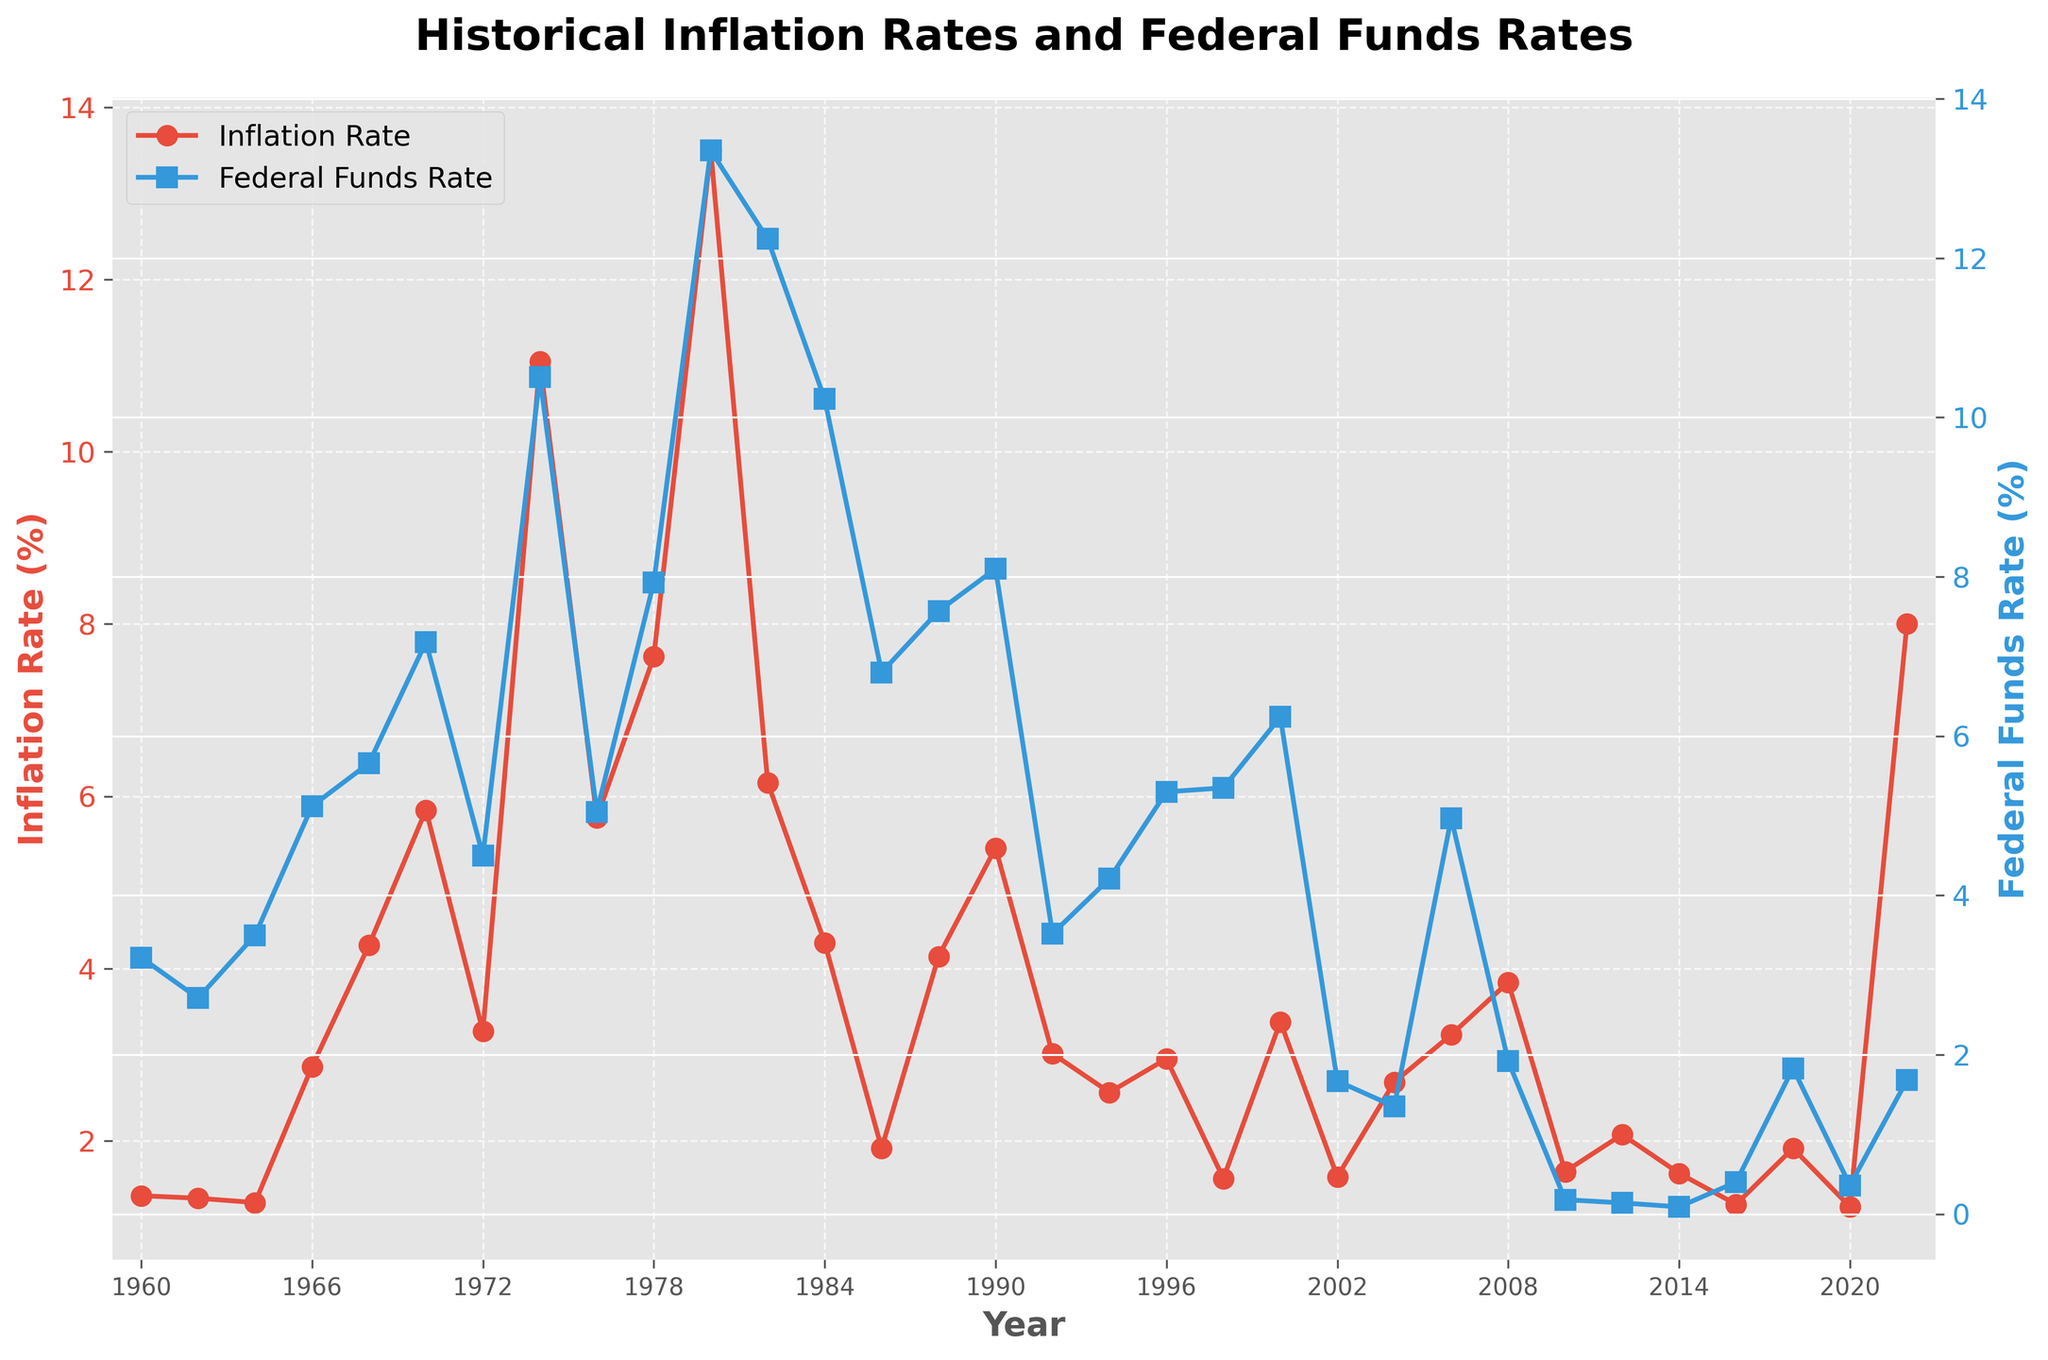Which year had the highest inflation rate? To determine the year with the highest inflation rate, look at the red line representing the inflation rate and find the highest point on this line. The data labels also help identify this year.
Answer: 1980 Which year had the lowest Federal Funds Rate? To determine the year with the lowest Federal Funds Rate, look at the blue line representing the Federal Funds Rate and identify the lowest point on this line. The data labels also assist in this identification.
Answer: 2014 In how many years did the inflation rate exceed 10%? Check the red line graph for years where the inflation rate is above 10%. Count the number of these occurrences.
Answer: 2 What was the inflation rate in 1990 compared to 1986? Look at the red line plot and find the data points for the years 1990 and 1986. Compare the values to determine which is higher or if they are equal.
Answer: 1990 was higher During which period was the gap between the Inflation Rate and Federal Funds Rate the highest? Examine the difference between the red and blue lines over the years. Identify the period where this vertical gap is the largest.
Answer: 1982 By how much did the Federal Funds Rate decrease between 1984 and 1986? Locate the data points for 1984 and 1986 on the blue line plot. Subtract the rate in 1986 from the rate in 1984 to find the difference.
Answer: 3.43% Compare the Inflation Rate in 2022 to the Federal Funds Rate in 2022. Find the rates for the year 2022 for both inflation (red line) and Federal Funds Rate (blue line) and compare which is higher.
Answer: Inflation Rate was higher Which color represents the Federal Funds Rate in the plot? Identify the color of the line that represents the Federal Funds Rate by looking at the blue line in the chart.
Answer: Blue How did the Federal Funds Rate change from 1960 to 1966? Examine the blue line from 1960 to 1966. Identify the Federal Funds Rate in 1960 and 1966 and note the trend (e.g., increase, decrease).
Answer: Increased What are the average rates of inflation and Federal Funds from 2000 to 2010? Identify the rates from 2000 to 2010 for both Inflation and Federal Funds Rate, sum them up separately and divide each by the number of years. Average Inflation = (3.38 + 1.58 + 2.68 + 3.23 + 3.84 + 1.64) / 6 and average Federal Funds Rate = (6.24 + 1.67 + 1.35 + 4.97 + 1.92 + 0.18) / 6.
Answer: 2.72% for Inflation, 2.72% for Federal Funds 